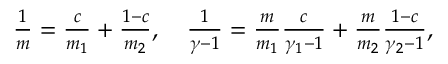<formula> <loc_0><loc_0><loc_500><loc_500>\begin{array} { r } { \frac { 1 } { m } = \frac { c } { m _ { 1 } } + \frac { 1 - c } { m _ { 2 } } , \quad \frac { 1 } { \gamma - 1 } = \frac { m } { m _ { 1 } } \frac { c } { \gamma _ { 1 } - 1 } + \frac { m } { m _ { 2 } } \frac { 1 - c } { \gamma _ { 2 } - 1 } , } \end{array}</formula> 